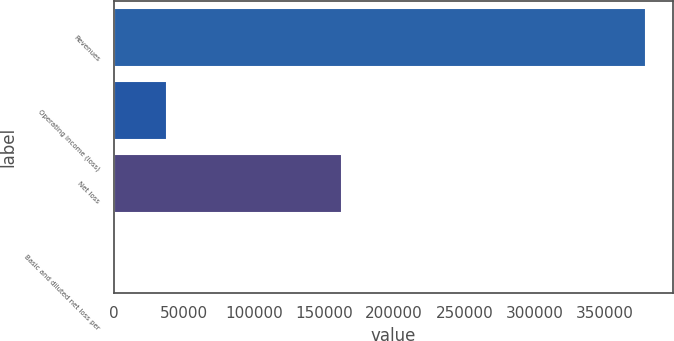Convert chart to OTSL. <chart><loc_0><loc_0><loc_500><loc_500><bar_chart><fcel>Revenues<fcel>Operating income (loss)<fcel>Net loss<fcel>Basic and diluted net loss per<nl><fcel>379863<fcel>37987.7<fcel>162573<fcel>1.57<nl></chart> 